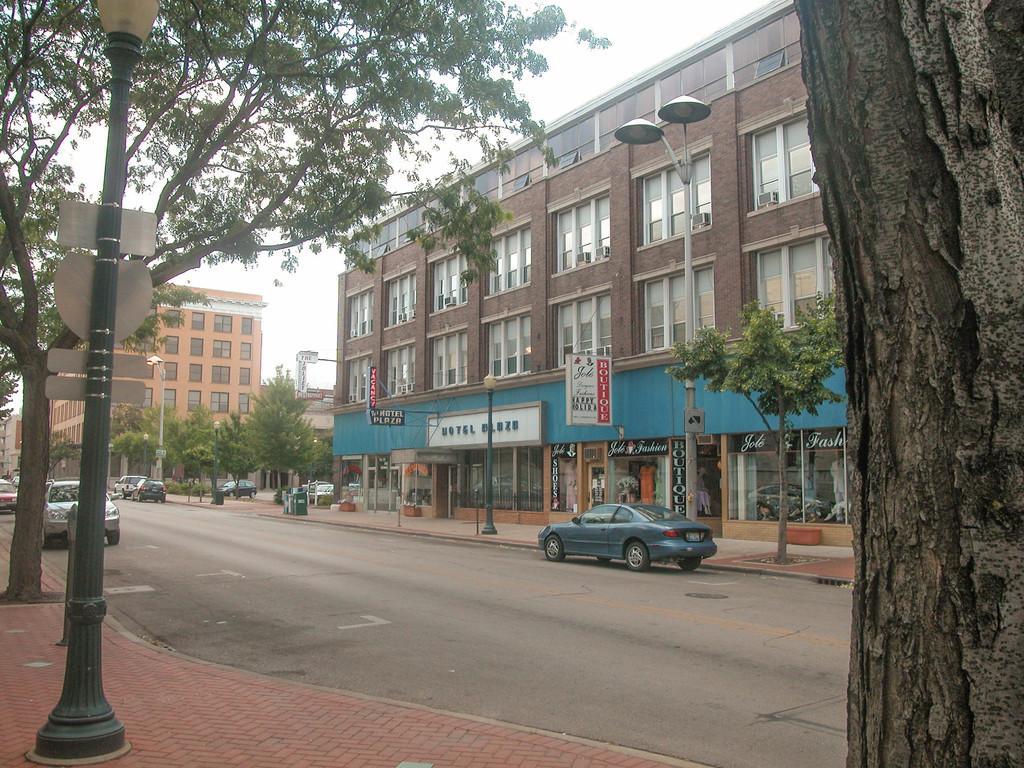How would you summarize this image in a sentence or two? In this image I can see there are cars on the road. And there is a sidewalk. On the sidewalk there are light poles. And at the right side there are buildings and a sign board. And at the top there is a sky. 